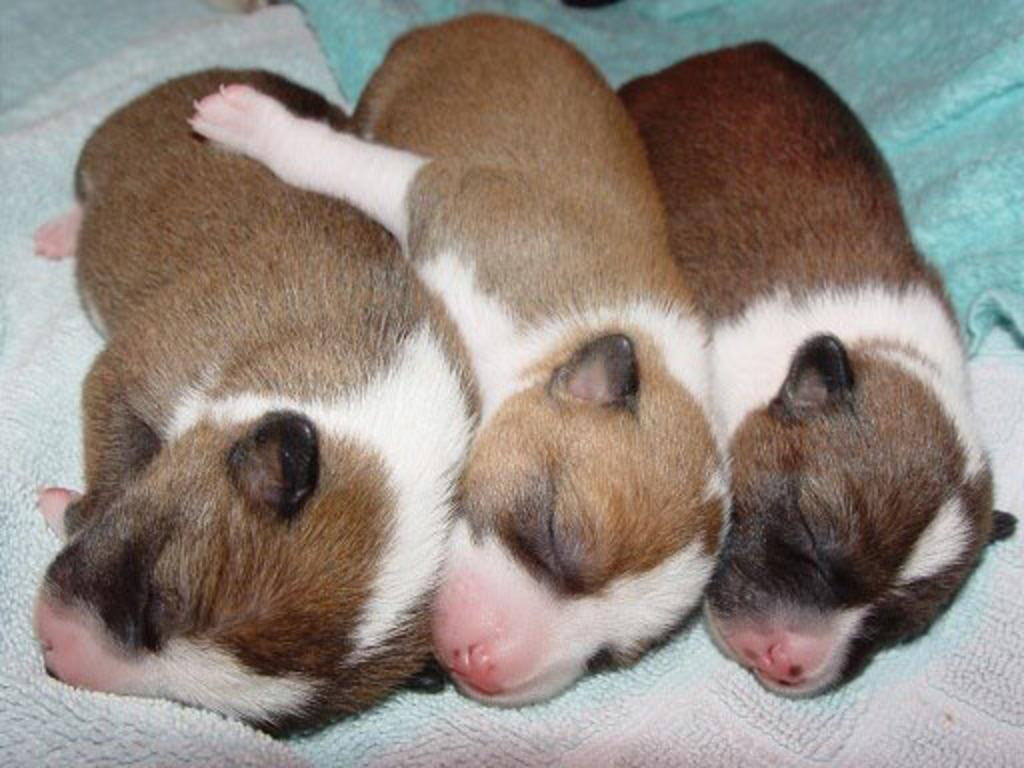How many dogs are present in the image? There are three dogs in the image. What are the dogs doing in the image? The dogs are sleeping. On what surface are the dogs resting in the image? The dogs are on a carpet. What type of ear is visible on the dogs in the image? There is no specific ear type mentioned in the image, as the focus is on the dogs being asleep on a carpet. 